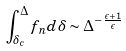<formula> <loc_0><loc_0><loc_500><loc_500>\int _ { \delta _ { c } } ^ { \Delta } f _ { n } d \delta \sim \Delta ^ { - \frac { \epsilon + 1 } { \epsilon } }</formula> 